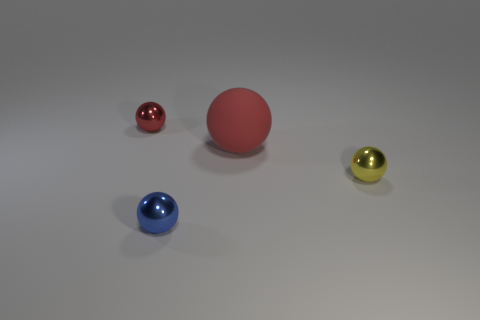Subtract all big matte spheres. How many spheres are left? 3 Subtract all red balls. How many balls are left? 2 Add 1 small yellow metallic balls. How many objects exist? 5 Subtract 0 yellow blocks. How many objects are left? 4 Subtract all gray balls. Subtract all green blocks. How many balls are left? 4 Subtract all cyan blocks. How many cyan balls are left? 0 Subtract all big green metal balls. Subtract all small spheres. How many objects are left? 1 Add 2 tiny shiny balls. How many tiny shiny balls are left? 5 Add 3 brown metal spheres. How many brown metal spheres exist? 3 